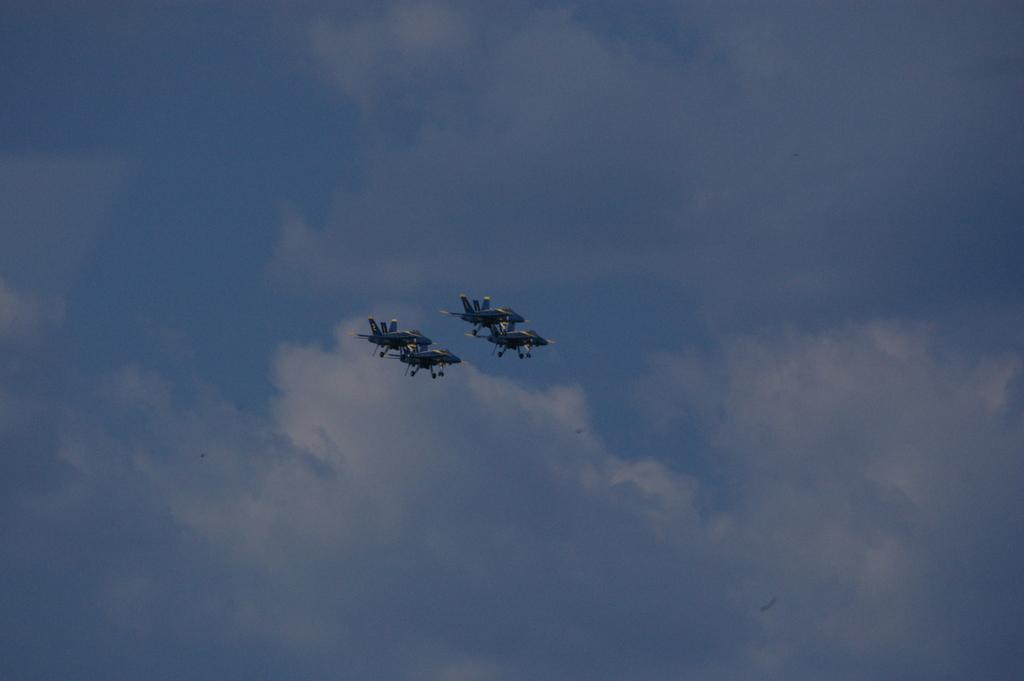What type of vehicles are present in the image? There are fighter aircrafts in the image. What are the aircrafts doing in the image? The aircrafts are flying in the air. What can be seen in the sky in the image? There are clouds visible in the sky. Can you tell me how many horses are pulling the carriage in the image? There is no horse or carriage present in the image; it features fighter aircrafts flying in the air. 